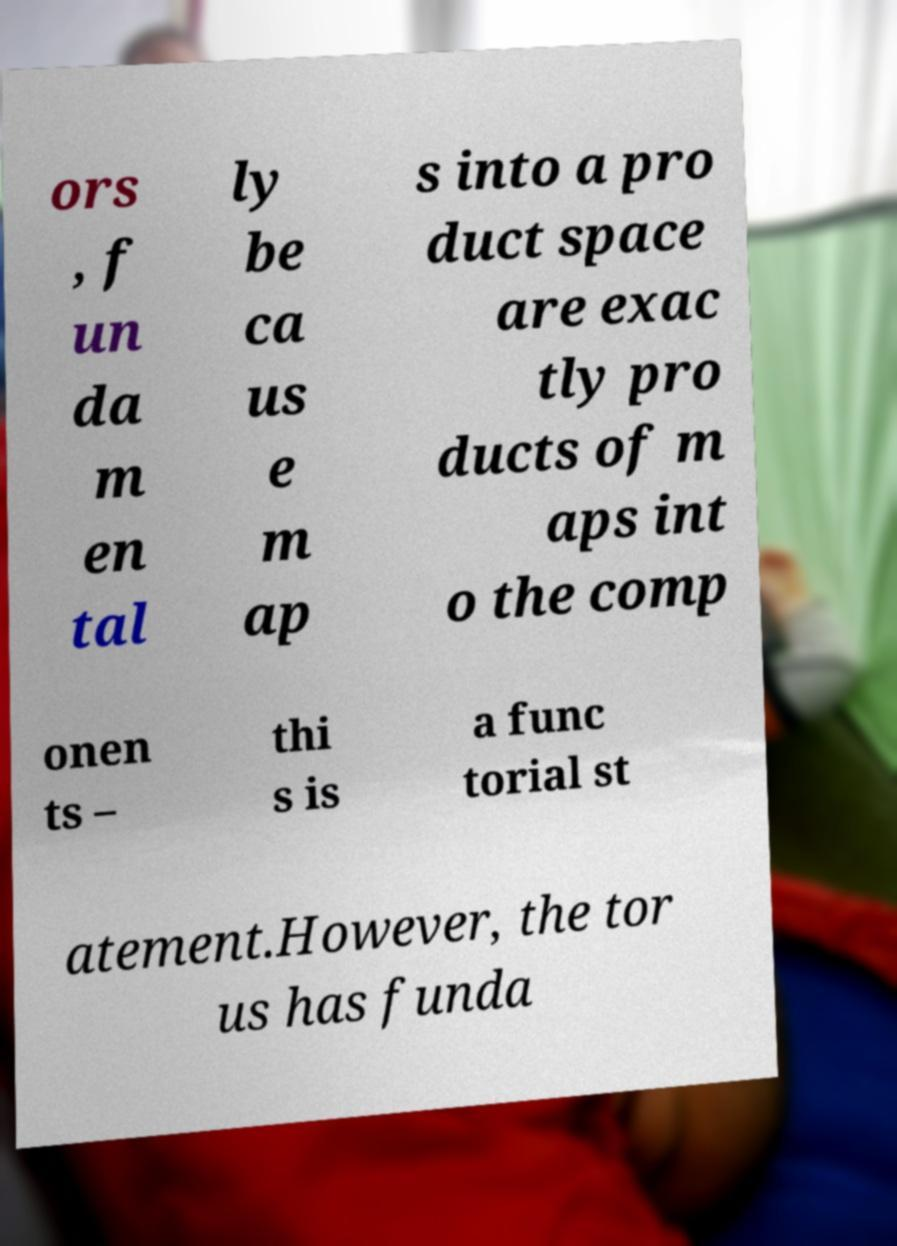There's text embedded in this image that I need extracted. Can you transcribe it verbatim? ors , f un da m en tal ly be ca us e m ap s into a pro duct space are exac tly pro ducts of m aps int o the comp onen ts – thi s is a func torial st atement.However, the tor us has funda 